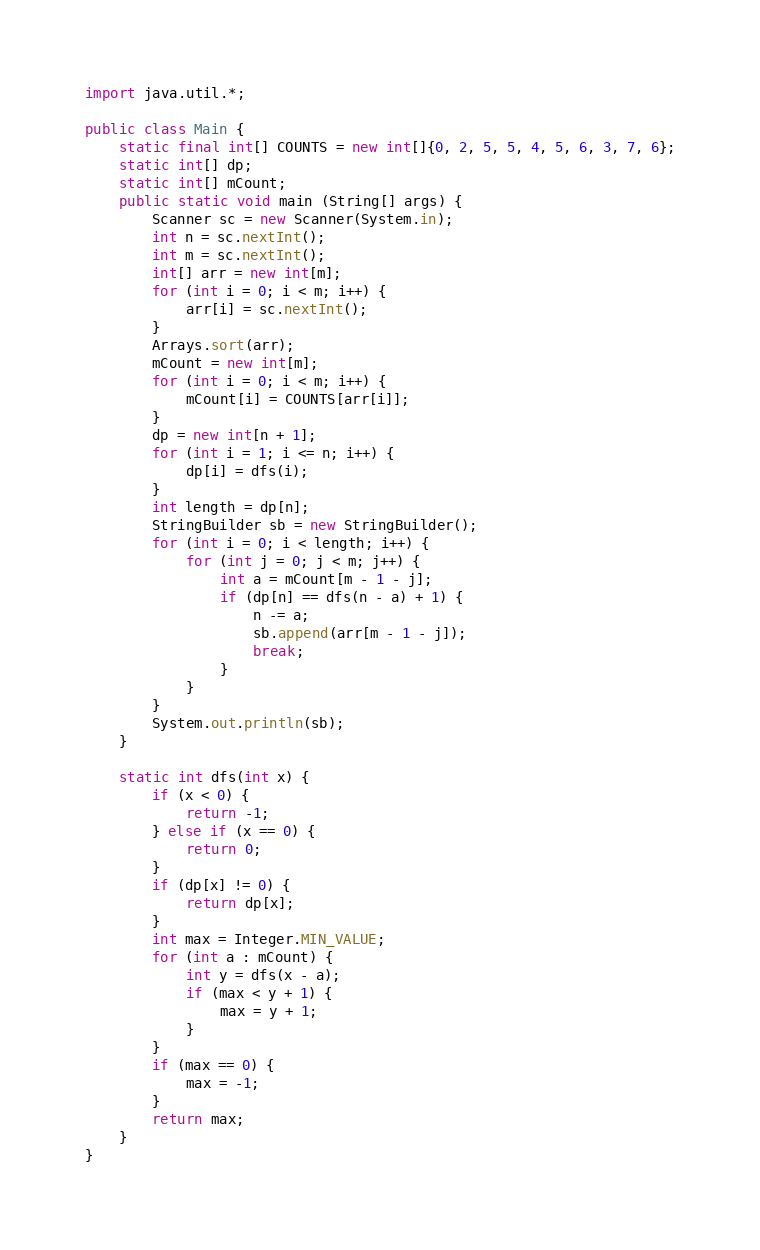<code> <loc_0><loc_0><loc_500><loc_500><_Java_>import java.util.*;

public class Main {
	static final int[] COUNTS = new int[]{0, 2, 5, 5, 4, 5, 6, 3, 7, 6};
	static int[] dp;
	static int[] mCount;
	public static void main (String[] args) {
		Scanner sc = new Scanner(System.in);
		int n = sc.nextInt();
		int m = sc.nextInt();
		int[] arr = new int[m];
		for (int i = 0; i < m; i++) {
			arr[i] = sc.nextInt();
		}
		Arrays.sort(arr);
		mCount = new int[m];
		for (int i = 0; i < m; i++) {
			mCount[i] = COUNTS[arr[i]];
		}
		dp = new int[n + 1];
		for (int i = 1; i <= n; i++) {
			dp[i] = dfs(i);
		}
		int length = dp[n];
		StringBuilder sb = new StringBuilder();
		for (int i = 0; i < length; i++) {
			for (int j = 0; j < m; j++) {
				int a = mCount[m - 1 - j];
				if (dp[n] == dfs(n - a) + 1) {
					n -= a;
					sb.append(arr[m - 1 - j]);
					break;
				}
			}
		}
		System.out.println(sb);
	}
	
	static int dfs(int x) {
		if (x < 0) {
			return -1;
		} else if (x == 0) {
			return 0;
		}
		if (dp[x] != 0) {
			return dp[x];
		}
		int max = Integer.MIN_VALUE;
		for (int a : mCount) {
			int y = dfs(x - a);
			if (max < y + 1) {
				max = y + 1;
			}
		}
		if (max == 0) {
			max = -1;
		}
		return max;
	}
}
</code> 